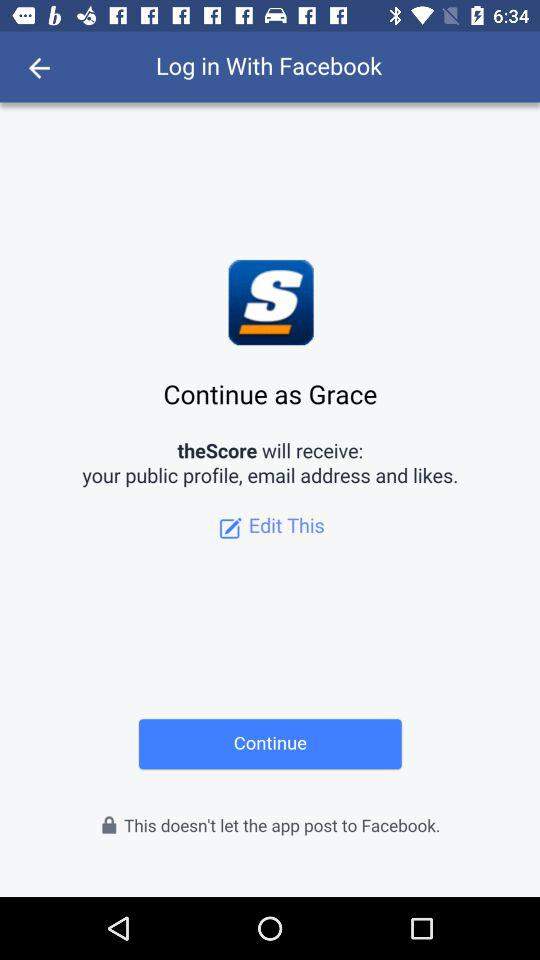What application will receive a public profile, an email address, and likes? The application is "theScore". 